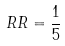Convert formula to latex. <formula><loc_0><loc_0><loc_500><loc_500>R R = \frac { 1 } { 5 }</formula> 